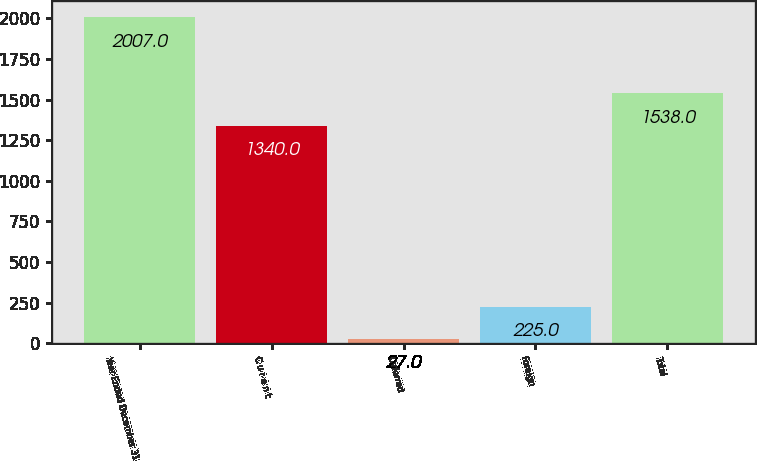<chart> <loc_0><loc_0><loc_500><loc_500><bar_chart><fcel>Year Ended December 31<fcel>C u r e n t<fcel>Deferred<fcel>Foreign<fcel>Total<nl><fcel>2007<fcel>1340<fcel>27<fcel>225<fcel>1538<nl></chart> 